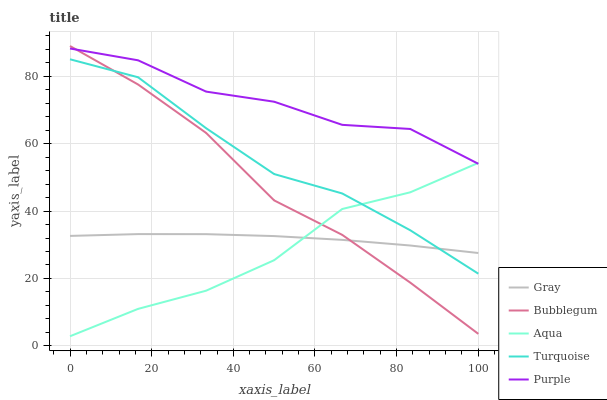Does Gray have the minimum area under the curve?
Answer yes or no. No. Does Gray have the maximum area under the curve?
Answer yes or no. No. Is Turquoise the smoothest?
Answer yes or no. No. Is Turquoise the roughest?
Answer yes or no. No. Does Gray have the lowest value?
Answer yes or no. No. Does Turquoise have the highest value?
Answer yes or no. No. Is Turquoise less than Purple?
Answer yes or no. Yes. Is Purple greater than Gray?
Answer yes or no. Yes. Does Turquoise intersect Purple?
Answer yes or no. No. 